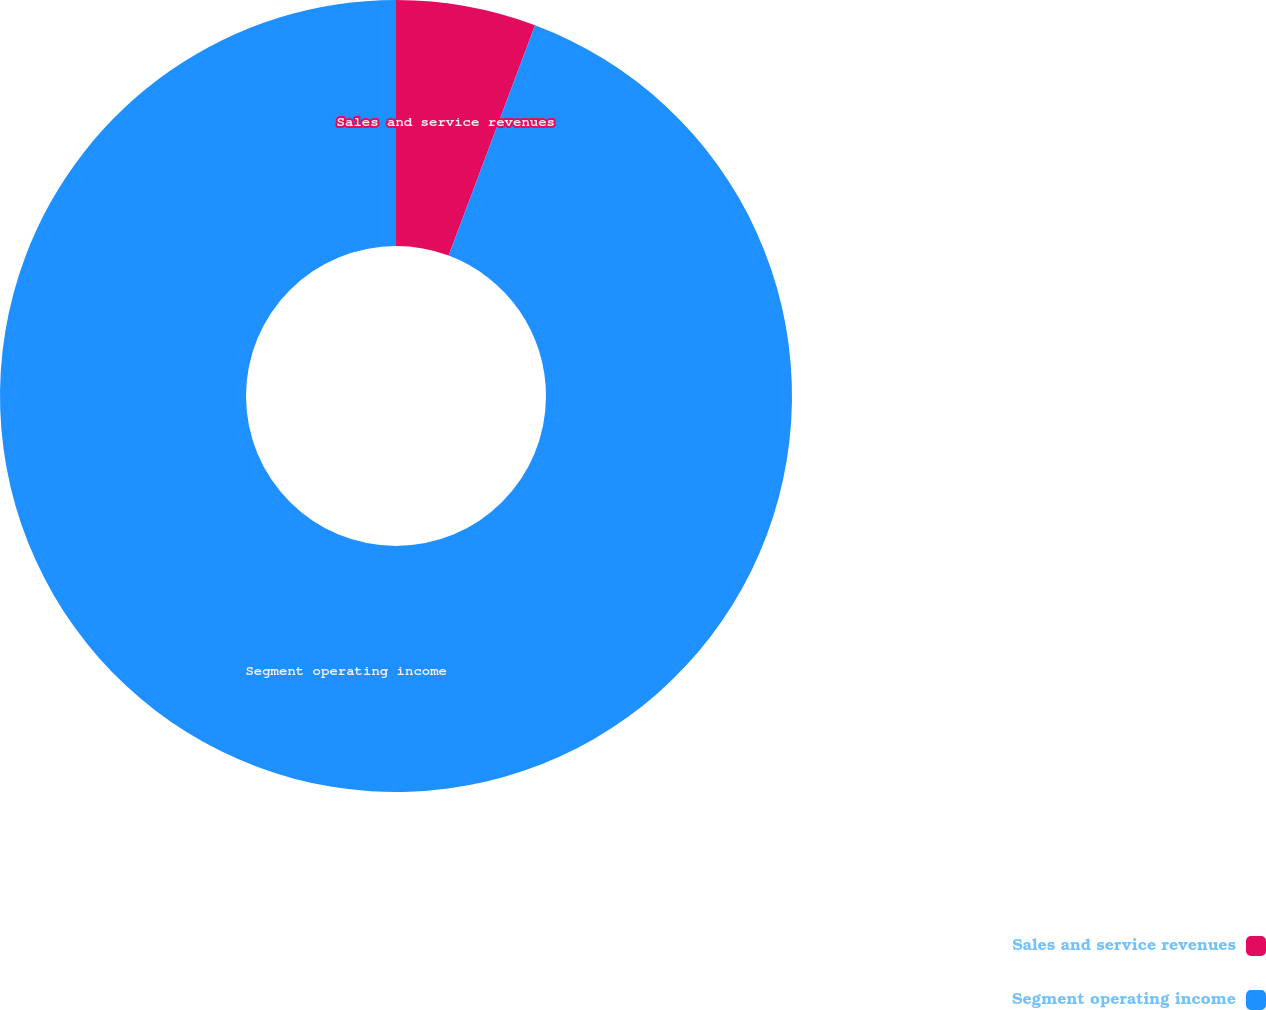Convert chart. <chart><loc_0><loc_0><loc_500><loc_500><pie_chart><fcel>Sales and service revenues<fcel>Segment operating income<nl><fcel>5.71%<fcel>94.29%<nl></chart> 